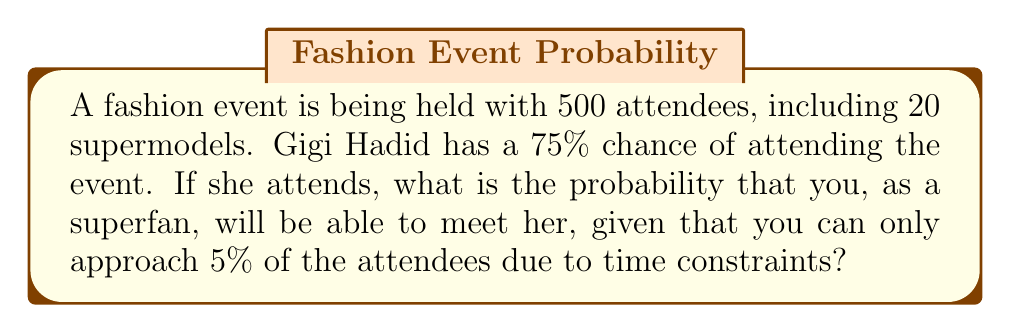What is the answer to this math problem? Let's break this down step-by-step:

1) First, we need to calculate the probability of Gigi Hadid attending the event:
   $P(\text{Gigi attends}) = 0.75$ or 75%

2) If Gigi attends, she will be one of the attendees you can approach. The number of attendees you can approach is:
   $500 \times 0.05 = 25$ attendees

3) The probability of meeting Gigi, given that she attends and that you can approach 25 people randomly, is:
   $P(\text{meet Gigi | Gigi attends}) = \frac{1}{500} \times 25 = \frac{1}{20} = 0.05$ or 5%

4) Now, we can use the law of total probability to calculate the overall probability of meeting Gigi:

   $P(\text{meet Gigi}) = P(\text{meet Gigi | Gigi attends}) \times P(\text{Gigi attends})$

5) Substituting the values:
   $P(\text{meet Gigi}) = 0.05 \times 0.75 = 0.0375$

Therefore, the probability of meeting Gigi Hadid at this fashion event is 0.0375 or 3.75%.
Answer: $0.0375$ or $3.75\%$ 